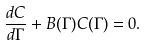<formula> <loc_0><loc_0><loc_500><loc_500>\frac { d C } { d \Gamma } + B ( \Gamma ) C ( \Gamma ) = 0 .</formula> 